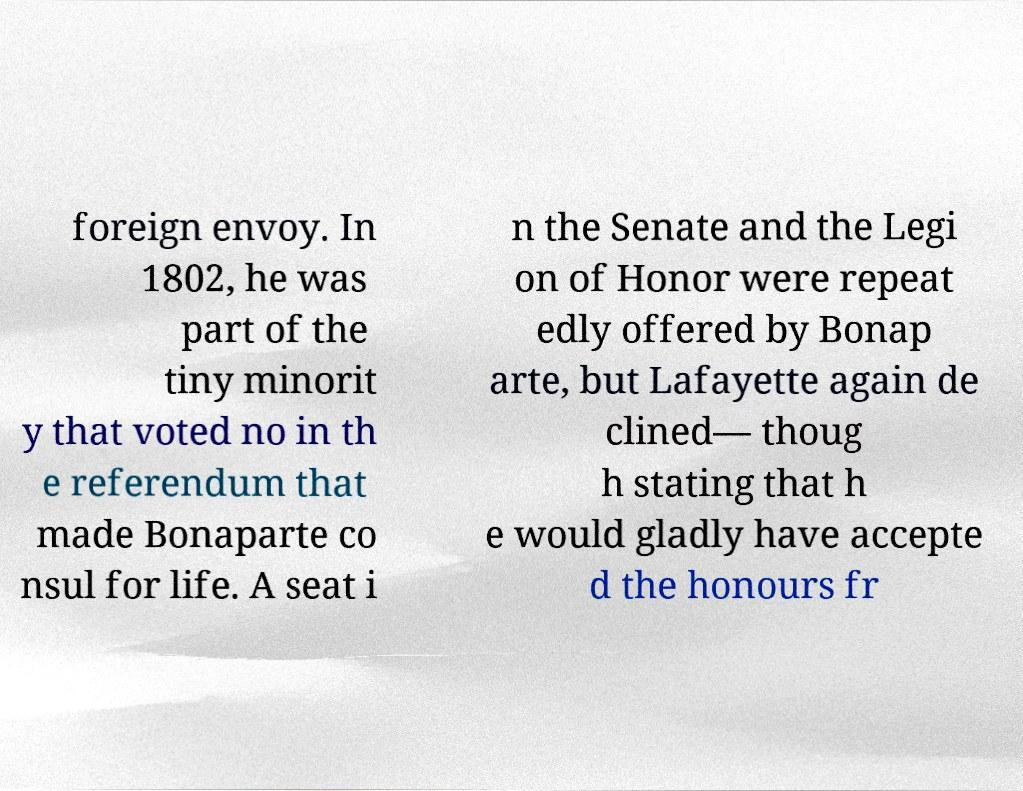Can you read and provide the text displayed in the image?This photo seems to have some interesting text. Can you extract and type it out for me? foreign envoy. In 1802, he was part of the tiny minorit y that voted no in th e referendum that made Bonaparte co nsul for life. A seat i n the Senate and the Legi on of Honor were repeat edly offered by Bonap arte, but Lafayette again de clined— thoug h stating that h e would gladly have accepte d the honours fr 